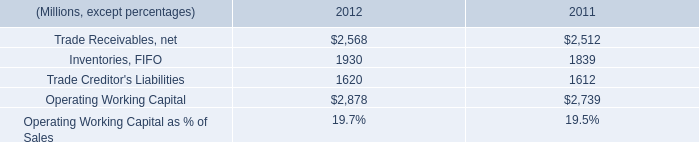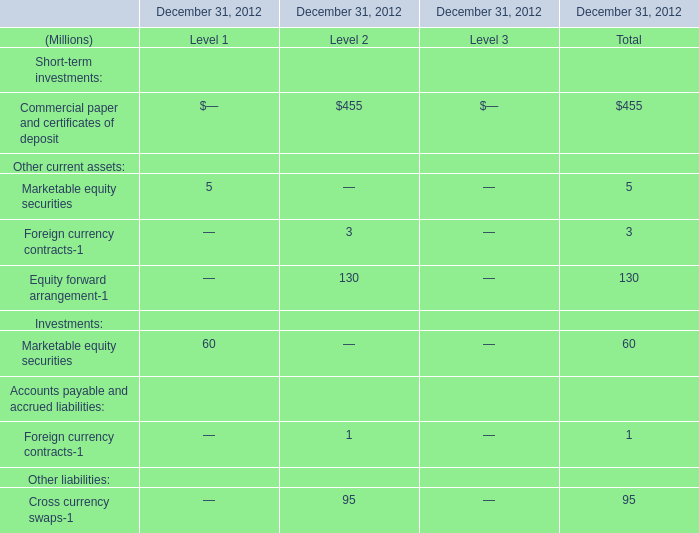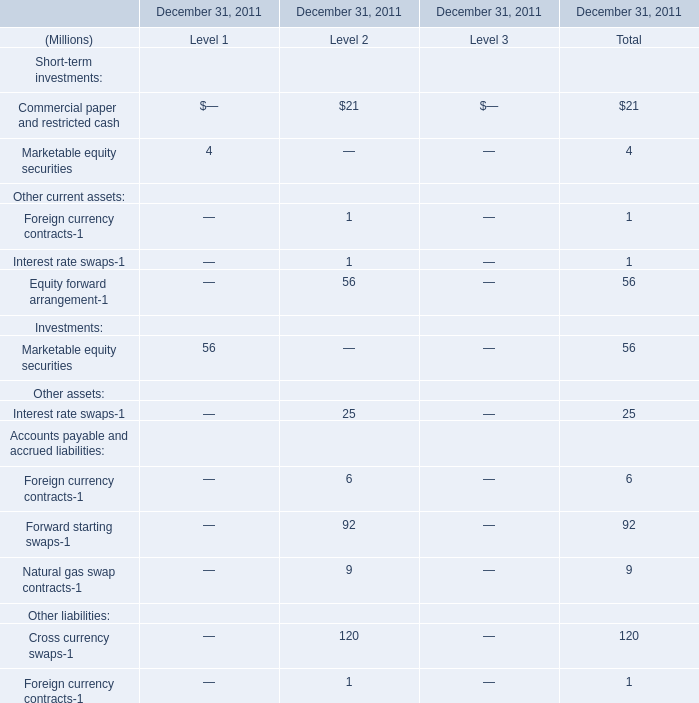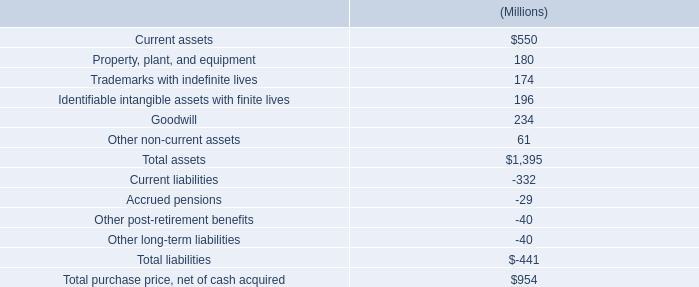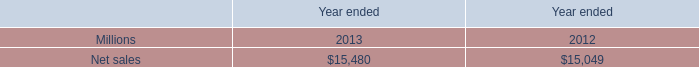what are cumulative three year dividends in millions? 
Computations: ((358 + 355) + 360)
Answer: 1073.0. 